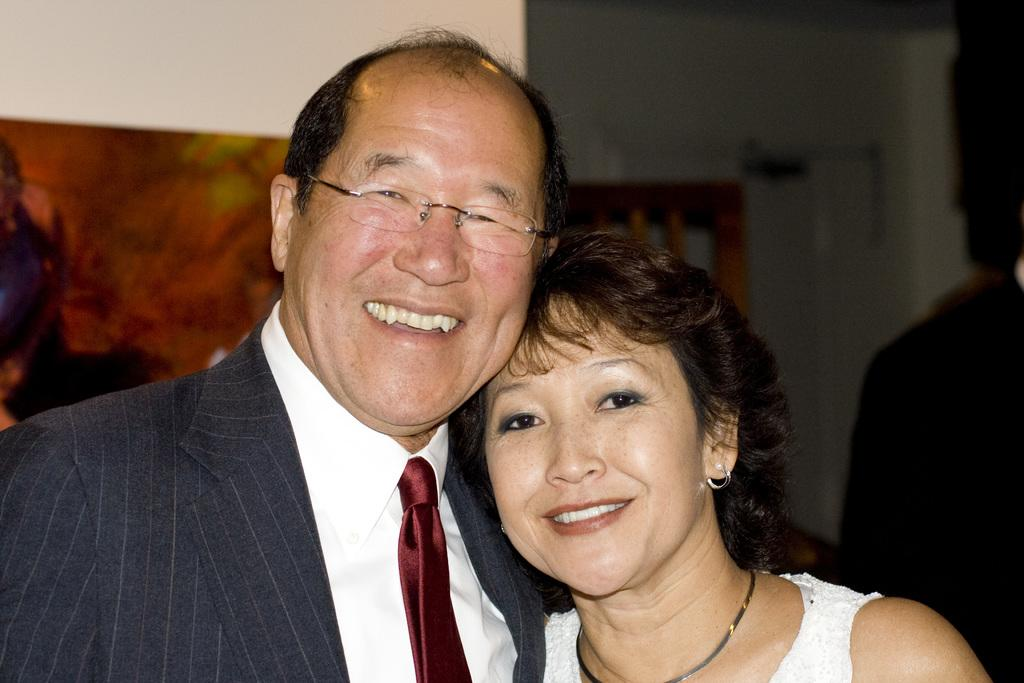Who is the main subject in the image? There is an old man in the image. What is the old man wearing? The old man is wearing a suit. Who else is present in the image? There is a woman in the image. What is the woman wearing, and what expression does she have? The woman is wearing a white dress and is smiling. Can you describe the background of the image? There is a person and a wall in the background of the image. What type of guitar can be seen in the hands of the old man in the image? There is no guitar present in the image; the old man is not holding any musical instrument. 